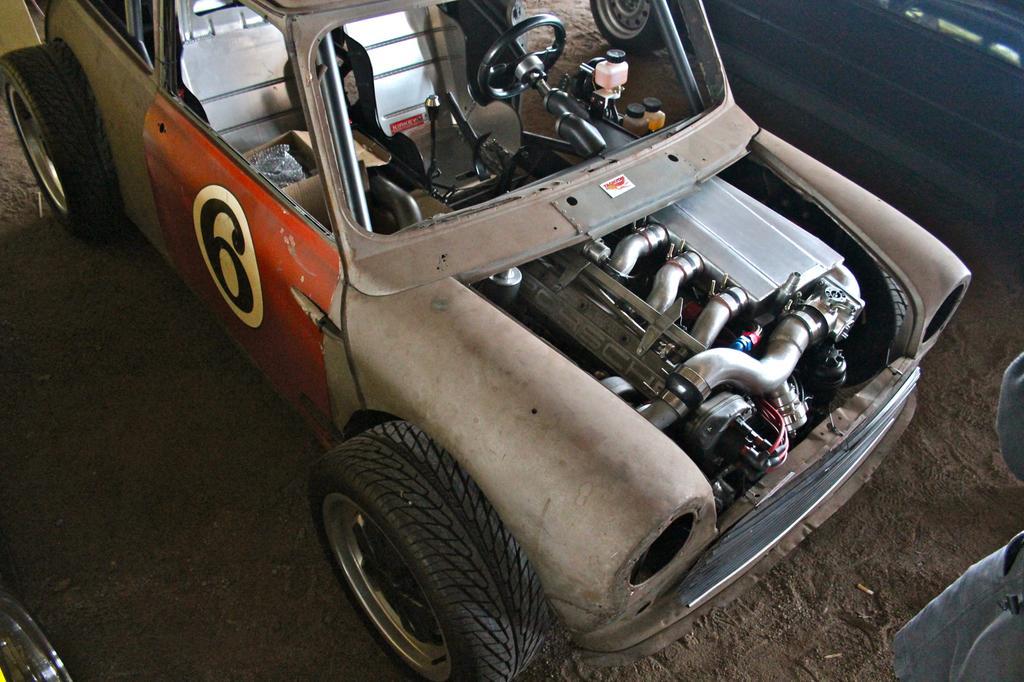Can you describe this image briefly? In this image in the front there is a car with some number written on it and on the right side there is an object which is grey in colour. On the top right there is a car which is blue in colour and on the bottom left there is a tyre. 